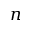Convert formula to latex. <formula><loc_0><loc_0><loc_500><loc_500>n</formula> 